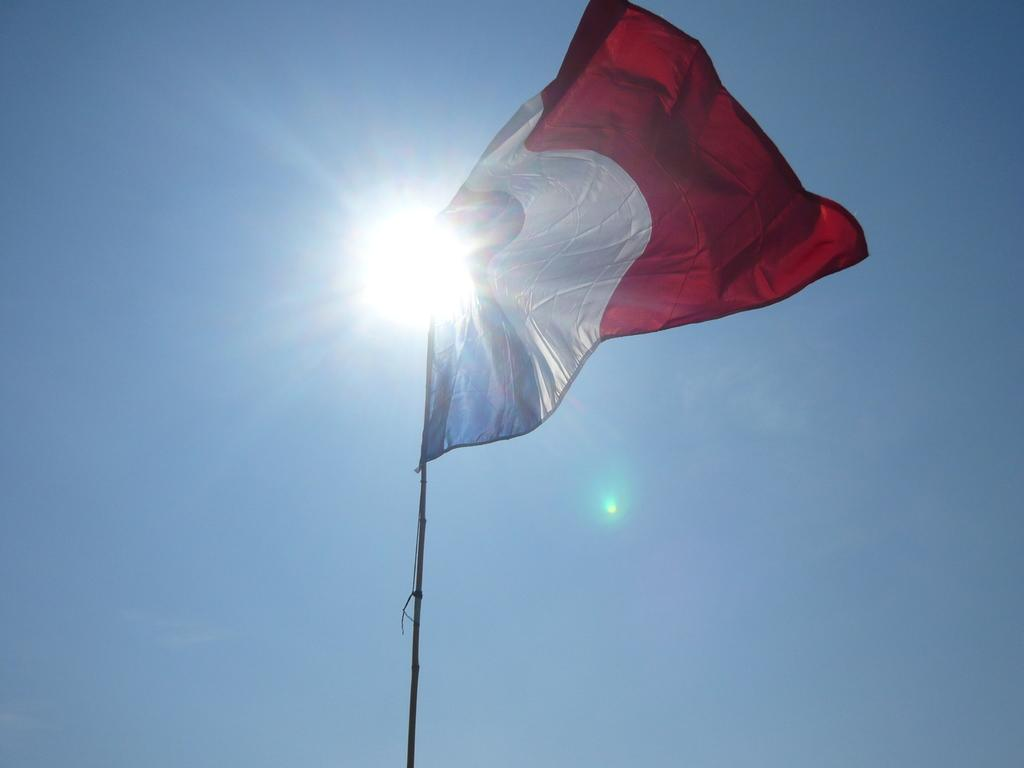What is the main object in the image? There is a flag in the image. What colors are present on the flag? The flag has blue, white, and red colors. How is the flag attached in the image? The flag is attached to a pole. What can be seen in the background of the image? The background of the image includes the sun and a blue sky. Can you see any windows in the image? There are no windows present in the image; it features a flag and a blue sky. What type of skirt is the flag made of? The flag is not a skirt; it is a piece of fabric attached to a pole, featuring blue, white, and red colors. 